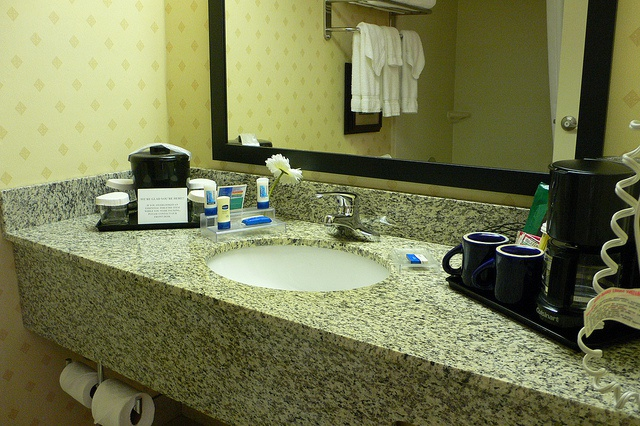Describe the objects in this image and their specific colors. I can see sink in khaki, beige, and darkgray tones, cup in khaki, black, navy, and beige tones, cup in khaki, black, beige, gray, and navy tones, cup in khaki, black, darkgreen, and gray tones, and cup in khaki, black, ivory, darkgreen, and tan tones in this image. 